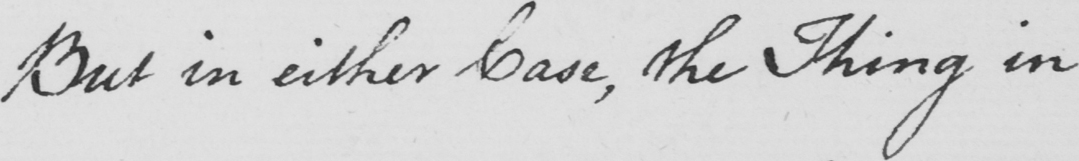Transcribe the text shown in this historical manuscript line. But in either Case , the Thing in 